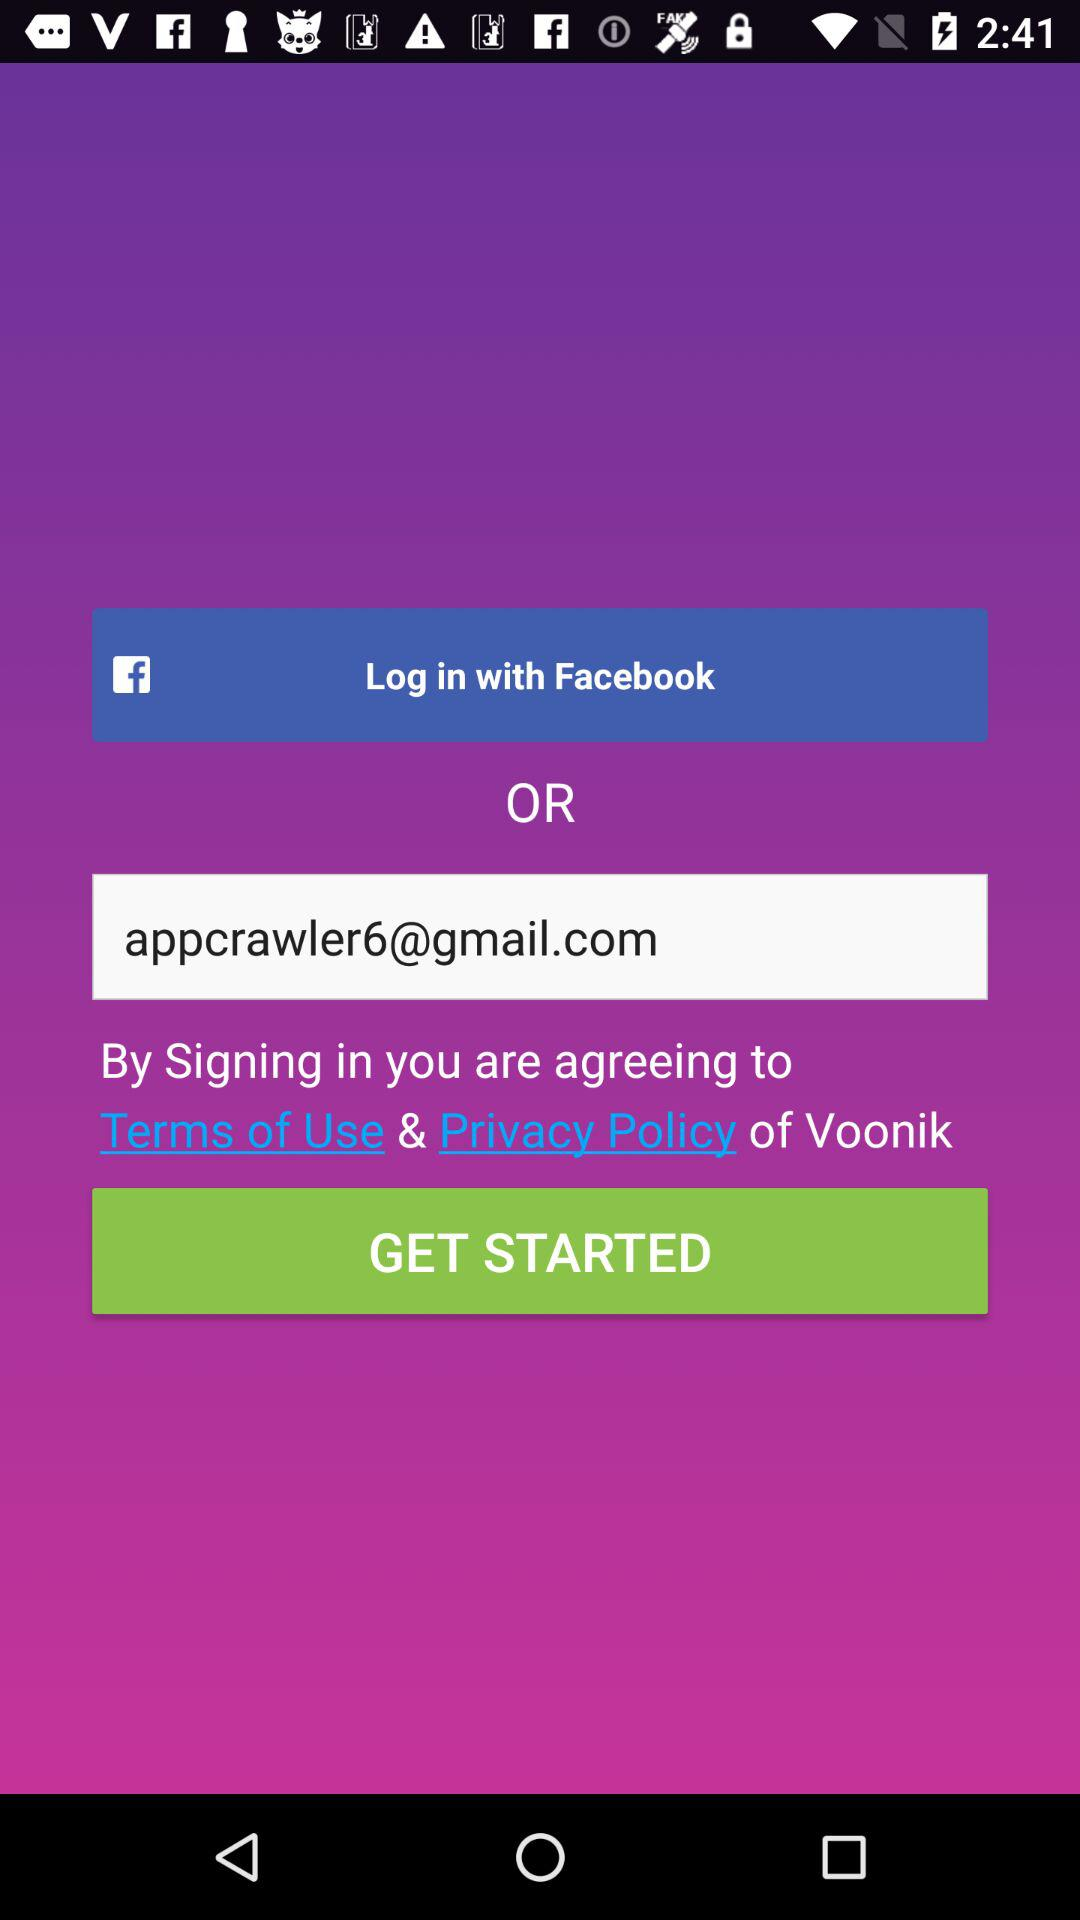What application can be used to log in to a profile? The application is "Facebook". 